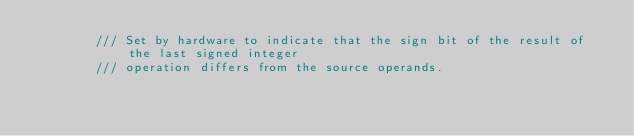Convert code to text. <code><loc_0><loc_0><loc_500><loc_500><_Rust_>        /// Set by hardware to indicate that the sign bit of the result of the last signed integer
        /// operation differs from the source operands.</code> 